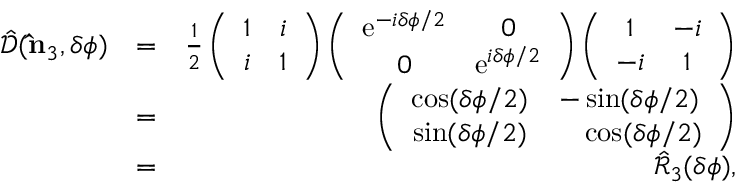Convert formula to latex. <formula><loc_0><loc_0><loc_500><loc_500>\begin{array} { r l r } { \hat { \mathcal { D } } ( { \hat { n } } _ { 3 } , \delta \phi ) } & { = } & { \frac { 1 } { 2 } \left ( \begin{array} { c c } { 1 } & { i } \\ { i } & { 1 } \end{array} \right ) \left ( \begin{array} { c c } { e ^ { - i \delta \phi / 2 } } & { 0 } \\ { 0 } & { e ^ { i \delta \phi / 2 } } \end{array} \right ) \left ( \begin{array} { c c } { 1 } & { - i } \\ { - i } & { 1 } \end{array} \right ) } \\ & { = } & { \left ( \begin{array} { c c } { \cos ( \delta \phi / 2 ) } & { - \sin ( \delta \phi / 2 ) } \\ { \sin ( \delta \phi / 2 ) } & { \quad \cos ( \delta \phi / 2 ) } \end{array} \right ) } \\ & { = } & { \hat { \mathcal { R } } _ { 3 } ( \delta \phi ) , } \end{array}</formula> 